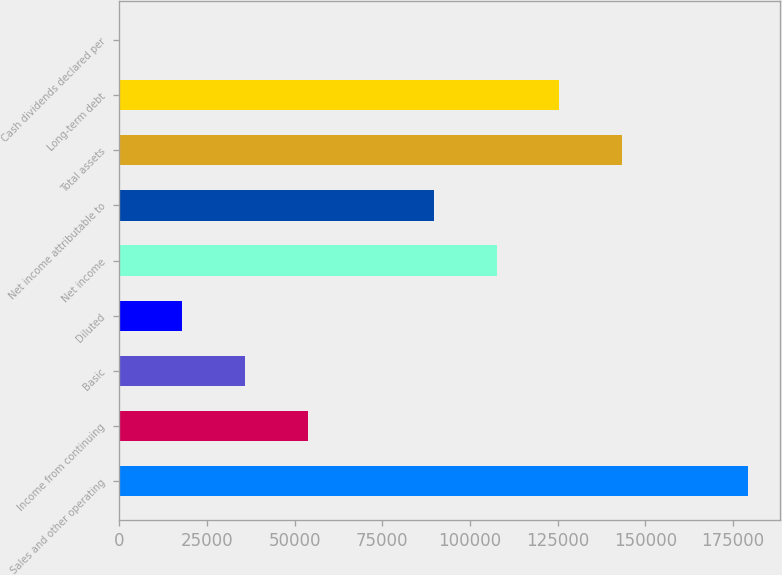<chart> <loc_0><loc_0><loc_500><loc_500><bar_chart><fcel>Sales and other operating<fcel>Income from continuing<fcel>Basic<fcel>Diluted<fcel>Net income<fcel>Net income attributable to<fcel>Total assets<fcel>Long-term debt<fcel>Cash dividends declared per<nl><fcel>179290<fcel>53787.3<fcel>35858.3<fcel>17929.4<fcel>107574<fcel>89645.2<fcel>143432<fcel>125503<fcel>0.45<nl></chart> 